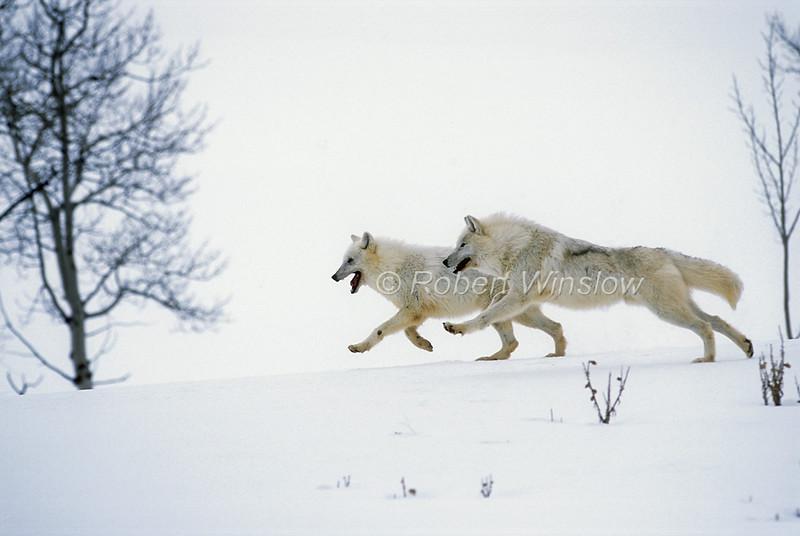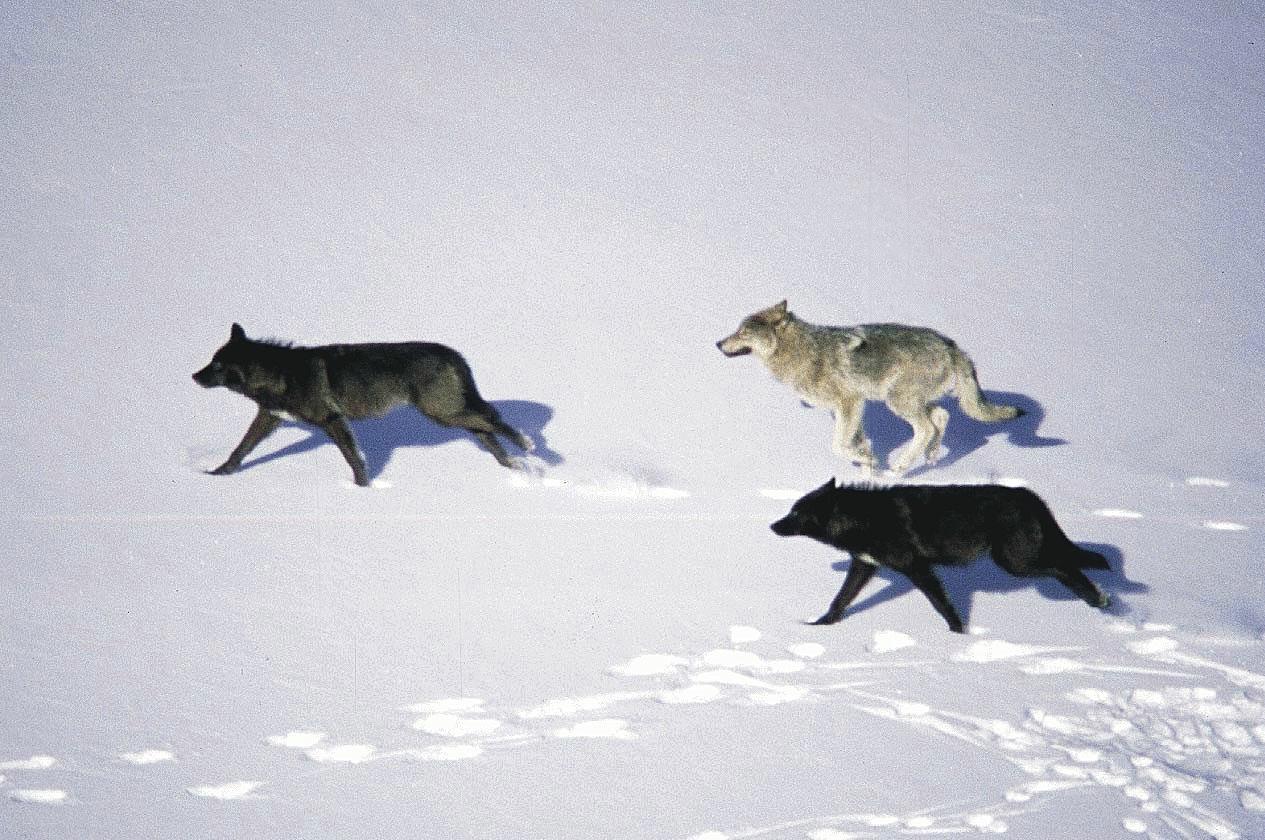The first image is the image on the left, the second image is the image on the right. For the images displayed, is the sentence "there are 5 wolves running in the snow in the image pair" factually correct? Answer yes or no. Yes. 